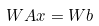Convert formula to latex. <formula><loc_0><loc_0><loc_500><loc_500>W A x = W b</formula> 